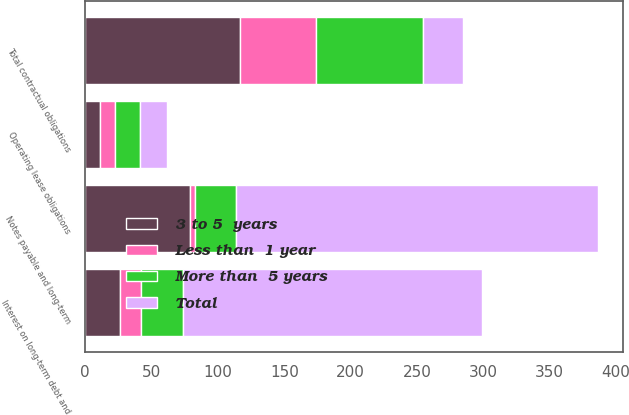<chart> <loc_0><loc_0><loc_500><loc_500><stacked_bar_chart><ecel><fcel>Notes payable and long-term<fcel>Interest on long-term debt and<fcel>Operating lease obligations<fcel>Total contractual obligations<nl><fcel>Less than  1 year<fcel>3.9<fcel>16.2<fcel>11.2<fcel>57<nl><fcel>More than  5 years<fcel>30.2<fcel>31.6<fcel>18.6<fcel>80.6<nl><fcel>3 to 5  years<fcel>79.2<fcel>26.2<fcel>11.3<fcel>116.7<nl><fcel>Total<fcel>272.7<fcel>224.9<fcel>20.2<fcel>30.2<nl></chart> 